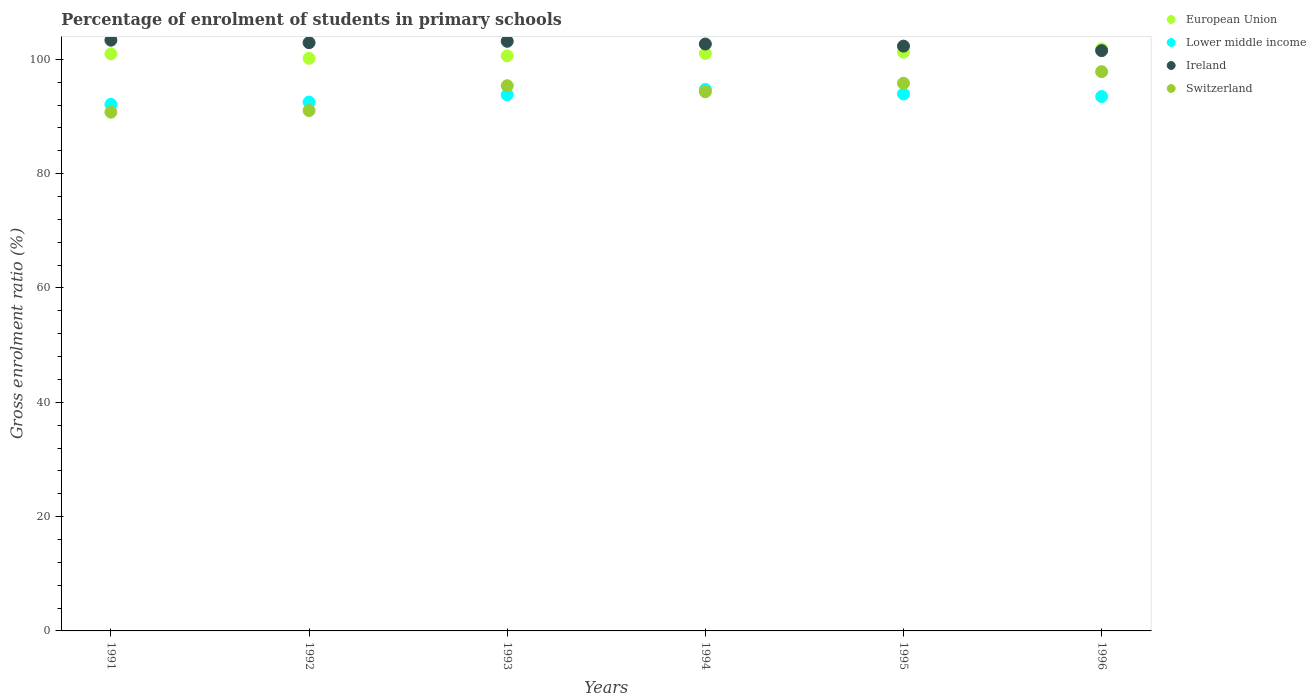Is the number of dotlines equal to the number of legend labels?
Your answer should be very brief. Yes. What is the percentage of students enrolled in primary schools in Ireland in 1993?
Make the answer very short. 103.16. Across all years, what is the maximum percentage of students enrolled in primary schools in European Union?
Offer a terse response. 101.84. Across all years, what is the minimum percentage of students enrolled in primary schools in Lower middle income?
Your response must be concise. 92.12. In which year was the percentage of students enrolled in primary schools in European Union minimum?
Provide a short and direct response. 1992. What is the total percentage of students enrolled in primary schools in Switzerland in the graph?
Keep it short and to the point. 565.19. What is the difference between the percentage of students enrolled in primary schools in European Union in 1992 and that in 1996?
Your response must be concise. -1.66. What is the difference between the percentage of students enrolled in primary schools in European Union in 1993 and the percentage of students enrolled in primary schools in Lower middle income in 1996?
Ensure brevity in your answer.  7.11. What is the average percentage of students enrolled in primary schools in Ireland per year?
Keep it short and to the point. 102.66. In the year 1991, what is the difference between the percentage of students enrolled in primary schools in Ireland and percentage of students enrolled in primary schools in Switzerland?
Provide a succinct answer. 12.59. What is the ratio of the percentage of students enrolled in primary schools in Lower middle income in 1992 to that in 1993?
Your answer should be compact. 0.99. Is the percentage of students enrolled in primary schools in Lower middle income in 1992 less than that in 1995?
Provide a succinct answer. Yes. Is the difference between the percentage of students enrolled in primary schools in Ireland in 1993 and 1994 greater than the difference between the percentage of students enrolled in primary schools in Switzerland in 1993 and 1994?
Your answer should be very brief. No. What is the difference between the highest and the second highest percentage of students enrolled in primary schools in Lower middle income?
Ensure brevity in your answer.  0.78. What is the difference between the highest and the lowest percentage of students enrolled in primary schools in Switzerland?
Keep it short and to the point. 7.09. Is it the case that in every year, the sum of the percentage of students enrolled in primary schools in Switzerland and percentage of students enrolled in primary schools in European Union  is greater than the sum of percentage of students enrolled in primary schools in Ireland and percentage of students enrolled in primary schools in Lower middle income?
Your response must be concise. Yes. Is it the case that in every year, the sum of the percentage of students enrolled in primary schools in European Union and percentage of students enrolled in primary schools in Lower middle income  is greater than the percentage of students enrolled in primary schools in Switzerland?
Provide a succinct answer. Yes. Is the percentage of students enrolled in primary schools in Lower middle income strictly greater than the percentage of students enrolled in primary schools in Ireland over the years?
Your answer should be very brief. No. Does the graph contain any zero values?
Offer a very short reply. No. Does the graph contain grids?
Provide a succinct answer. No. What is the title of the graph?
Offer a very short reply. Percentage of enrolment of students in primary schools. What is the label or title of the X-axis?
Provide a succinct answer. Years. What is the label or title of the Y-axis?
Offer a terse response. Gross enrolment ratio (%). What is the Gross enrolment ratio (%) in European Union in 1991?
Ensure brevity in your answer.  100.97. What is the Gross enrolment ratio (%) in Lower middle income in 1991?
Ensure brevity in your answer.  92.12. What is the Gross enrolment ratio (%) in Ireland in 1991?
Make the answer very short. 103.36. What is the Gross enrolment ratio (%) of Switzerland in 1991?
Offer a very short reply. 90.76. What is the Gross enrolment ratio (%) of European Union in 1992?
Provide a succinct answer. 100.18. What is the Gross enrolment ratio (%) in Lower middle income in 1992?
Offer a very short reply. 92.52. What is the Gross enrolment ratio (%) in Ireland in 1992?
Provide a succinct answer. 102.92. What is the Gross enrolment ratio (%) of Switzerland in 1992?
Ensure brevity in your answer.  91.04. What is the Gross enrolment ratio (%) in European Union in 1993?
Your answer should be compact. 100.61. What is the Gross enrolment ratio (%) of Lower middle income in 1993?
Offer a terse response. 93.81. What is the Gross enrolment ratio (%) of Ireland in 1993?
Make the answer very short. 103.16. What is the Gross enrolment ratio (%) of Switzerland in 1993?
Provide a short and direct response. 95.38. What is the Gross enrolment ratio (%) of European Union in 1994?
Offer a very short reply. 101.04. What is the Gross enrolment ratio (%) in Lower middle income in 1994?
Provide a succinct answer. 94.74. What is the Gross enrolment ratio (%) of Ireland in 1994?
Make the answer very short. 102.68. What is the Gross enrolment ratio (%) of Switzerland in 1994?
Provide a short and direct response. 94.33. What is the Gross enrolment ratio (%) of European Union in 1995?
Keep it short and to the point. 101.26. What is the Gross enrolment ratio (%) in Lower middle income in 1995?
Ensure brevity in your answer.  93.96. What is the Gross enrolment ratio (%) of Ireland in 1995?
Ensure brevity in your answer.  102.31. What is the Gross enrolment ratio (%) of Switzerland in 1995?
Your response must be concise. 95.83. What is the Gross enrolment ratio (%) in European Union in 1996?
Make the answer very short. 101.84. What is the Gross enrolment ratio (%) in Lower middle income in 1996?
Your response must be concise. 93.5. What is the Gross enrolment ratio (%) of Ireland in 1996?
Offer a very short reply. 101.52. What is the Gross enrolment ratio (%) of Switzerland in 1996?
Provide a succinct answer. 97.85. Across all years, what is the maximum Gross enrolment ratio (%) of European Union?
Offer a very short reply. 101.84. Across all years, what is the maximum Gross enrolment ratio (%) of Lower middle income?
Your answer should be compact. 94.74. Across all years, what is the maximum Gross enrolment ratio (%) in Ireland?
Make the answer very short. 103.36. Across all years, what is the maximum Gross enrolment ratio (%) of Switzerland?
Keep it short and to the point. 97.85. Across all years, what is the minimum Gross enrolment ratio (%) of European Union?
Provide a succinct answer. 100.18. Across all years, what is the minimum Gross enrolment ratio (%) of Lower middle income?
Make the answer very short. 92.12. Across all years, what is the minimum Gross enrolment ratio (%) in Ireland?
Give a very brief answer. 101.52. Across all years, what is the minimum Gross enrolment ratio (%) of Switzerland?
Offer a very short reply. 90.76. What is the total Gross enrolment ratio (%) in European Union in the graph?
Make the answer very short. 605.89. What is the total Gross enrolment ratio (%) of Lower middle income in the graph?
Give a very brief answer. 560.64. What is the total Gross enrolment ratio (%) in Ireland in the graph?
Give a very brief answer. 615.95. What is the total Gross enrolment ratio (%) of Switzerland in the graph?
Make the answer very short. 565.19. What is the difference between the Gross enrolment ratio (%) in European Union in 1991 and that in 1992?
Your response must be concise. 0.79. What is the difference between the Gross enrolment ratio (%) in Lower middle income in 1991 and that in 1992?
Your answer should be very brief. -0.4. What is the difference between the Gross enrolment ratio (%) in Ireland in 1991 and that in 1992?
Your response must be concise. 0.44. What is the difference between the Gross enrolment ratio (%) in Switzerland in 1991 and that in 1992?
Offer a terse response. -0.28. What is the difference between the Gross enrolment ratio (%) of European Union in 1991 and that in 1993?
Give a very brief answer. 0.35. What is the difference between the Gross enrolment ratio (%) of Lower middle income in 1991 and that in 1993?
Provide a succinct answer. -1.69. What is the difference between the Gross enrolment ratio (%) of Ireland in 1991 and that in 1993?
Your answer should be compact. 0.2. What is the difference between the Gross enrolment ratio (%) in Switzerland in 1991 and that in 1993?
Your response must be concise. -4.62. What is the difference between the Gross enrolment ratio (%) in European Union in 1991 and that in 1994?
Offer a very short reply. -0.07. What is the difference between the Gross enrolment ratio (%) of Lower middle income in 1991 and that in 1994?
Ensure brevity in your answer.  -2.62. What is the difference between the Gross enrolment ratio (%) of Ireland in 1991 and that in 1994?
Your answer should be compact. 0.67. What is the difference between the Gross enrolment ratio (%) of Switzerland in 1991 and that in 1994?
Provide a succinct answer. -3.57. What is the difference between the Gross enrolment ratio (%) of European Union in 1991 and that in 1995?
Offer a very short reply. -0.29. What is the difference between the Gross enrolment ratio (%) of Lower middle income in 1991 and that in 1995?
Your answer should be compact. -1.84. What is the difference between the Gross enrolment ratio (%) of Ireland in 1991 and that in 1995?
Make the answer very short. 1.04. What is the difference between the Gross enrolment ratio (%) of Switzerland in 1991 and that in 1995?
Keep it short and to the point. -5.06. What is the difference between the Gross enrolment ratio (%) of European Union in 1991 and that in 1996?
Provide a short and direct response. -0.87. What is the difference between the Gross enrolment ratio (%) of Lower middle income in 1991 and that in 1996?
Provide a short and direct response. -1.38. What is the difference between the Gross enrolment ratio (%) of Ireland in 1991 and that in 1996?
Make the answer very short. 1.83. What is the difference between the Gross enrolment ratio (%) of Switzerland in 1991 and that in 1996?
Offer a terse response. -7.09. What is the difference between the Gross enrolment ratio (%) of European Union in 1992 and that in 1993?
Provide a succinct answer. -0.43. What is the difference between the Gross enrolment ratio (%) of Lower middle income in 1992 and that in 1993?
Ensure brevity in your answer.  -1.29. What is the difference between the Gross enrolment ratio (%) in Ireland in 1992 and that in 1993?
Offer a terse response. -0.24. What is the difference between the Gross enrolment ratio (%) of Switzerland in 1992 and that in 1993?
Ensure brevity in your answer.  -4.34. What is the difference between the Gross enrolment ratio (%) of European Union in 1992 and that in 1994?
Offer a very short reply. -0.86. What is the difference between the Gross enrolment ratio (%) in Lower middle income in 1992 and that in 1994?
Your answer should be very brief. -2.22. What is the difference between the Gross enrolment ratio (%) of Ireland in 1992 and that in 1994?
Provide a succinct answer. 0.24. What is the difference between the Gross enrolment ratio (%) in Switzerland in 1992 and that in 1994?
Offer a terse response. -3.29. What is the difference between the Gross enrolment ratio (%) in European Union in 1992 and that in 1995?
Ensure brevity in your answer.  -1.08. What is the difference between the Gross enrolment ratio (%) of Lower middle income in 1992 and that in 1995?
Ensure brevity in your answer.  -1.44. What is the difference between the Gross enrolment ratio (%) in Ireland in 1992 and that in 1995?
Your answer should be compact. 0.6. What is the difference between the Gross enrolment ratio (%) of Switzerland in 1992 and that in 1995?
Ensure brevity in your answer.  -4.78. What is the difference between the Gross enrolment ratio (%) of European Union in 1992 and that in 1996?
Your answer should be very brief. -1.66. What is the difference between the Gross enrolment ratio (%) of Lower middle income in 1992 and that in 1996?
Give a very brief answer. -0.98. What is the difference between the Gross enrolment ratio (%) of Ireland in 1992 and that in 1996?
Give a very brief answer. 1.39. What is the difference between the Gross enrolment ratio (%) of Switzerland in 1992 and that in 1996?
Ensure brevity in your answer.  -6.8. What is the difference between the Gross enrolment ratio (%) in European Union in 1993 and that in 1994?
Make the answer very short. -0.43. What is the difference between the Gross enrolment ratio (%) in Lower middle income in 1993 and that in 1994?
Your answer should be very brief. -0.93. What is the difference between the Gross enrolment ratio (%) of Ireland in 1993 and that in 1994?
Your answer should be very brief. 0.48. What is the difference between the Gross enrolment ratio (%) of Switzerland in 1993 and that in 1994?
Provide a short and direct response. 1.05. What is the difference between the Gross enrolment ratio (%) in European Union in 1993 and that in 1995?
Give a very brief answer. -0.64. What is the difference between the Gross enrolment ratio (%) in Lower middle income in 1993 and that in 1995?
Ensure brevity in your answer.  -0.15. What is the difference between the Gross enrolment ratio (%) of Ireland in 1993 and that in 1995?
Offer a terse response. 0.85. What is the difference between the Gross enrolment ratio (%) of Switzerland in 1993 and that in 1995?
Your answer should be very brief. -0.44. What is the difference between the Gross enrolment ratio (%) of European Union in 1993 and that in 1996?
Ensure brevity in your answer.  -1.22. What is the difference between the Gross enrolment ratio (%) of Lower middle income in 1993 and that in 1996?
Provide a short and direct response. 0.31. What is the difference between the Gross enrolment ratio (%) of Ireland in 1993 and that in 1996?
Provide a short and direct response. 1.64. What is the difference between the Gross enrolment ratio (%) in Switzerland in 1993 and that in 1996?
Ensure brevity in your answer.  -2.47. What is the difference between the Gross enrolment ratio (%) of European Union in 1994 and that in 1995?
Provide a succinct answer. -0.22. What is the difference between the Gross enrolment ratio (%) in Lower middle income in 1994 and that in 1995?
Offer a terse response. 0.78. What is the difference between the Gross enrolment ratio (%) of Ireland in 1994 and that in 1995?
Ensure brevity in your answer.  0.37. What is the difference between the Gross enrolment ratio (%) of Switzerland in 1994 and that in 1995?
Provide a succinct answer. -1.49. What is the difference between the Gross enrolment ratio (%) of European Union in 1994 and that in 1996?
Provide a succinct answer. -0.79. What is the difference between the Gross enrolment ratio (%) of Lower middle income in 1994 and that in 1996?
Your answer should be compact. 1.24. What is the difference between the Gross enrolment ratio (%) in Ireland in 1994 and that in 1996?
Provide a short and direct response. 1.16. What is the difference between the Gross enrolment ratio (%) of Switzerland in 1994 and that in 1996?
Give a very brief answer. -3.52. What is the difference between the Gross enrolment ratio (%) of European Union in 1995 and that in 1996?
Provide a short and direct response. -0.58. What is the difference between the Gross enrolment ratio (%) of Lower middle income in 1995 and that in 1996?
Ensure brevity in your answer.  0.46. What is the difference between the Gross enrolment ratio (%) of Ireland in 1995 and that in 1996?
Offer a terse response. 0.79. What is the difference between the Gross enrolment ratio (%) in Switzerland in 1995 and that in 1996?
Your answer should be compact. -2.02. What is the difference between the Gross enrolment ratio (%) in European Union in 1991 and the Gross enrolment ratio (%) in Lower middle income in 1992?
Provide a succinct answer. 8.45. What is the difference between the Gross enrolment ratio (%) in European Union in 1991 and the Gross enrolment ratio (%) in Ireland in 1992?
Your answer should be very brief. -1.95. What is the difference between the Gross enrolment ratio (%) in European Union in 1991 and the Gross enrolment ratio (%) in Switzerland in 1992?
Offer a terse response. 9.92. What is the difference between the Gross enrolment ratio (%) of Lower middle income in 1991 and the Gross enrolment ratio (%) of Ireland in 1992?
Keep it short and to the point. -10.8. What is the difference between the Gross enrolment ratio (%) of Lower middle income in 1991 and the Gross enrolment ratio (%) of Switzerland in 1992?
Provide a short and direct response. 1.08. What is the difference between the Gross enrolment ratio (%) in Ireland in 1991 and the Gross enrolment ratio (%) in Switzerland in 1992?
Make the answer very short. 12.31. What is the difference between the Gross enrolment ratio (%) of European Union in 1991 and the Gross enrolment ratio (%) of Lower middle income in 1993?
Ensure brevity in your answer.  7.16. What is the difference between the Gross enrolment ratio (%) in European Union in 1991 and the Gross enrolment ratio (%) in Ireland in 1993?
Your response must be concise. -2.19. What is the difference between the Gross enrolment ratio (%) of European Union in 1991 and the Gross enrolment ratio (%) of Switzerland in 1993?
Offer a very short reply. 5.58. What is the difference between the Gross enrolment ratio (%) in Lower middle income in 1991 and the Gross enrolment ratio (%) in Ireland in 1993?
Give a very brief answer. -11.04. What is the difference between the Gross enrolment ratio (%) in Lower middle income in 1991 and the Gross enrolment ratio (%) in Switzerland in 1993?
Ensure brevity in your answer.  -3.26. What is the difference between the Gross enrolment ratio (%) of Ireland in 1991 and the Gross enrolment ratio (%) of Switzerland in 1993?
Make the answer very short. 7.97. What is the difference between the Gross enrolment ratio (%) of European Union in 1991 and the Gross enrolment ratio (%) of Lower middle income in 1994?
Provide a short and direct response. 6.23. What is the difference between the Gross enrolment ratio (%) in European Union in 1991 and the Gross enrolment ratio (%) in Ireland in 1994?
Offer a very short reply. -1.71. What is the difference between the Gross enrolment ratio (%) of European Union in 1991 and the Gross enrolment ratio (%) of Switzerland in 1994?
Offer a terse response. 6.64. What is the difference between the Gross enrolment ratio (%) in Lower middle income in 1991 and the Gross enrolment ratio (%) in Ireland in 1994?
Offer a very short reply. -10.56. What is the difference between the Gross enrolment ratio (%) of Lower middle income in 1991 and the Gross enrolment ratio (%) of Switzerland in 1994?
Ensure brevity in your answer.  -2.21. What is the difference between the Gross enrolment ratio (%) in Ireland in 1991 and the Gross enrolment ratio (%) in Switzerland in 1994?
Offer a terse response. 9.02. What is the difference between the Gross enrolment ratio (%) of European Union in 1991 and the Gross enrolment ratio (%) of Lower middle income in 1995?
Keep it short and to the point. 7.01. What is the difference between the Gross enrolment ratio (%) of European Union in 1991 and the Gross enrolment ratio (%) of Ireland in 1995?
Offer a very short reply. -1.35. What is the difference between the Gross enrolment ratio (%) in European Union in 1991 and the Gross enrolment ratio (%) in Switzerland in 1995?
Offer a very short reply. 5.14. What is the difference between the Gross enrolment ratio (%) of Lower middle income in 1991 and the Gross enrolment ratio (%) of Ireland in 1995?
Offer a very short reply. -10.19. What is the difference between the Gross enrolment ratio (%) in Lower middle income in 1991 and the Gross enrolment ratio (%) in Switzerland in 1995?
Provide a short and direct response. -3.7. What is the difference between the Gross enrolment ratio (%) in Ireland in 1991 and the Gross enrolment ratio (%) in Switzerland in 1995?
Provide a succinct answer. 7.53. What is the difference between the Gross enrolment ratio (%) of European Union in 1991 and the Gross enrolment ratio (%) of Lower middle income in 1996?
Your answer should be very brief. 7.47. What is the difference between the Gross enrolment ratio (%) of European Union in 1991 and the Gross enrolment ratio (%) of Ireland in 1996?
Your answer should be very brief. -0.56. What is the difference between the Gross enrolment ratio (%) in European Union in 1991 and the Gross enrolment ratio (%) in Switzerland in 1996?
Give a very brief answer. 3.12. What is the difference between the Gross enrolment ratio (%) in Lower middle income in 1991 and the Gross enrolment ratio (%) in Ireland in 1996?
Your answer should be compact. -9.4. What is the difference between the Gross enrolment ratio (%) of Lower middle income in 1991 and the Gross enrolment ratio (%) of Switzerland in 1996?
Your answer should be very brief. -5.73. What is the difference between the Gross enrolment ratio (%) of Ireland in 1991 and the Gross enrolment ratio (%) of Switzerland in 1996?
Offer a terse response. 5.51. What is the difference between the Gross enrolment ratio (%) of European Union in 1992 and the Gross enrolment ratio (%) of Lower middle income in 1993?
Make the answer very short. 6.37. What is the difference between the Gross enrolment ratio (%) in European Union in 1992 and the Gross enrolment ratio (%) in Ireland in 1993?
Keep it short and to the point. -2.98. What is the difference between the Gross enrolment ratio (%) in European Union in 1992 and the Gross enrolment ratio (%) in Switzerland in 1993?
Offer a very short reply. 4.8. What is the difference between the Gross enrolment ratio (%) of Lower middle income in 1992 and the Gross enrolment ratio (%) of Ireland in 1993?
Provide a succinct answer. -10.64. What is the difference between the Gross enrolment ratio (%) in Lower middle income in 1992 and the Gross enrolment ratio (%) in Switzerland in 1993?
Give a very brief answer. -2.86. What is the difference between the Gross enrolment ratio (%) of Ireland in 1992 and the Gross enrolment ratio (%) of Switzerland in 1993?
Provide a succinct answer. 7.53. What is the difference between the Gross enrolment ratio (%) in European Union in 1992 and the Gross enrolment ratio (%) in Lower middle income in 1994?
Ensure brevity in your answer.  5.44. What is the difference between the Gross enrolment ratio (%) of European Union in 1992 and the Gross enrolment ratio (%) of Ireland in 1994?
Your response must be concise. -2.5. What is the difference between the Gross enrolment ratio (%) of European Union in 1992 and the Gross enrolment ratio (%) of Switzerland in 1994?
Give a very brief answer. 5.85. What is the difference between the Gross enrolment ratio (%) in Lower middle income in 1992 and the Gross enrolment ratio (%) in Ireland in 1994?
Offer a very short reply. -10.16. What is the difference between the Gross enrolment ratio (%) of Lower middle income in 1992 and the Gross enrolment ratio (%) of Switzerland in 1994?
Provide a short and direct response. -1.81. What is the difference between the Gross enrolment ratio (%) of Ireland in 1992 and the Gross enrolment ratio (%) of Switzerland in 1994?
Provide a succinct answer. 8.59. What is the difference between the Gross enrolment ratio (%) in European Union in 1992 and the Gross enrolment ratio (%) in Lower middle income in 1995?
Make the answer very short. 6.22. What is the difference between the Gross enrolment ratio (%) of European Union in 1992 and the Gross enrolment ratio (%) of Ireland in 1995?
Make the answer very short. -2.13. What is the difference between the Gross enrolment ratio (%) in European Union in 1992 and the Gross enrolment ratio (%) in Switzerland in 1995?
Offer a very short reply. 4.35. What is the difference between the Gross enrolment ratio (%) of Lower middle income in 1992 and the Gross enrolment ratio (%) of Ireland in 1995?
Provide a succinct answer. -9.79. What is the difference between the Gross enrolment ratio (%) in Lower middle income in 1992 and the Gross enrolment ratio (%) in Switzerland in 1995?
Offer a very short reply. -3.3. What is the difference between the Gross enrolment ratio (%) in Ireland in 1992 and the Gross enrolment ratio (%) in Switzerland in 1995?
Give a very brief answer. 7.09. What is the difference between the Gross enrolment ratio (%) in European Union in 1992 and the Gross enrolment ratio (%) in Lower middle income in 1996?
Give a very brief answer. 6.68. What is the difference between the Gross enrolment ratio (%) of European Union in 1992 and the Gross enrolment ratio (%) of Ireland in 1996?
Make the answer very short. -1.34. What is the difference between the Gross enrolment ratio (%) of European Union in 1992 and the Gross enrolment ratio (%) of Switzerland in 1996?
Your response must be concise. 2.33. What is the difference between the Gross enrolment ratio (%) of Lower middle income in 1992 and the Gross enrolment ratio (%) of Ireland in 1996?
Your response must be concise. -9. What is the difference between the Gross enrolment ratio (%) in Lower middle income in 1992 and the Gross enrolment ratio (%) in Switzerland in 1996?
Give a very brief answer. -5.33. What is the difference between the Gross enrolment ratio (%) of Ireland in 1992 and the Gross enrolment ratio (%) of Switzerland in 1996?
Offer a terse response. 5.07. What is the difference between the Gross enrolment ratio (%) in European Union in 1993 and the Gross enrolment ratio (%) in Lower middle income in 1994?
Ensure brevity in your answer.  5.88. What is the difference between the Gross enrolment ratio (%) in European Union in 1993 and the Gross enrolment ratio (%) in Ireland in 1994?
Provide a short and direct response. -2.07. What is the difference between the Gross enrolment ratio (%) of European Union in 1993 and the Gross enrolment ratio (%) of Switzerland in 1994?
Your answer should be very brief. 6.28. What is the difference between the Gross enrolment ratio (%) of Lower middle income in 1993 and the Gross enrolment ratio (%) of Ireland in 1994?
Your answer should be compact. -8.87. What is the difference between the Gross enrolment ratio (%) in Lower middle income in 1993 and the Gross enrolment ratio (%) in Switzerland in 1994?
Make the answer very short. -0.52. What is the difference between the Gross enrolment ratio (%) in Ireland in 1993 and the Gross enrolment ratio (%) in Switzerland in 1994?
Your answer should be compact. 8.83. What is the difference between the Gross enrolment ratio (%) of European Union in 1993 and the Gross enrolment ratio (%) of Lower middle income in 1995?
Give a very brief answer. 6.65. What is the difference between the Gross enrolment ratio (%) in European Union in 1993 and the Gross enrolment ratio (%) in Ireland in 1995?
Your response must be concise. -1.7. What is the difference between the Gross enrolment ratio (%) of European Union in 1993 and the Gross enrolment ratio (%) of Switzerland in 1995?
Your answer should be compact. 4.79. What is the difference between the Gross enrolment ratio (%) of Lower middle income in 1993 and the Gross enrolment ratio (%) of Ireland in 1995?
Ensure brevity in your answer.  -8.5. What is the difference between the Gross enrolment ratio (%) in Lower middle income in 1993 and the Gross enrolment ratio (%) in Switzerland in 1995?
Your response must be concise. -2.02. What is the difference between the Gross enrolment ratio (%) in Ireland in 1993 and the Gross enrolment ratio (%) in Switzerland in 1995?
Your answer should be very brief. 7.33. What is the difference between the Gross enrolment ratio (%) of European Union in 1993 and the Gross enrolment ratio (%) of Lower middle income in 1996?
Ensure brevity in your answer.  7.11. What is the difference between the Gross enrolment ratio (%) in European Union in 1993 and the Gross enrolment ratio (%) in Ireland in 1996?
Give a very brief answer. -0.91. What is the difference between the Gross enrolment ratio (%) of European Union in 1993 and the Gross enrolment ratio (%) of Switzerland in 1996?
Keep it short and to the point. 2.76. What is the difference between the Gross enrolment ratio (%) of Lower middle income in 1993 and the Gross enrolment ratio (%) of Ireland in 1996?
Keep it short and to the point. -7.71. What is the difference between the Gross enrolment ratio (%) of Lower middle income in 1993 and the Gross enrolment ratio (%) of Switzerland in 1996?
Make the answer very short. -4.04. What is the difference between the Gross enrolment ratio (%) of Ireland in 1993 and the Gross enrolment ratio (%) of Switzerland in 1996?
Make the answer very short. 5.31. What is the difference between the Gross enrolment ratio (%) in European Union in 1994 and the Gross enrolment ratio (%) in Lower middle income in 1995?
Make the answer very short. 7.08. What is the difference between the Gross enrolment ratio (%) in European Union in 1994 and the Gross enrolment ratio (%) in Ireland in 1995?
Your response must be concise. -1.27. What is the difference between the Gross enrolment ratio (%) of European Union in 1994 and the Gross enrolment ratio (%) of Switzerland in 1995?
Offer a very short reply. 5.22. What is the difference between the Gross enrolment ratio (%) in Lower middle income in 1994 and the Gross enrolment ratio (%) in Ireland in 1995?
Provide a short and direct response. -7.58. What is the difference between the Gross enrolment ratio (%) in Lower middle income in 1994 and the Gross enrolment ratio (%) in Switzerland in 1995?
Keep it short and to the point. -1.09. What is the difference between the Gross enrolment ratio (%) in Ireland in 1994 and the Gross enrolment ratio (%) in Switzerland in 1995?
Give a very brief answer. 6.86. What is the difference between the Gross enrolment ratio (%) in European Union in 1994 and the Gross enrolment ratio (%) in Lower middle income in 1996?
Make the answer very short. 7.54. What is the difference between the Gross enrolment ratio (%) of European Union in 1994 and the Gross enrolment ratio (%) of Ireland in 1996?
Ensure brevity in your answer.  -0.48. What is the difference between the Gross enrolment ratio (%) of European Union in 1994 and the Gross enrolment ratio (%) of Switzerland in 1996?
Offer a very short reply. 3.19. What is the difference between the Gross enrolment ratio (%) of Lower middle income in 1994 and the Gross enrolment ratio (%) of Ireland in 1996?
Provide a short and direct response. -6.79. What is the difference between the Gross enrolment ratio (%) in Lower middle income in 1994 and the Gross enrolment ratio (%) in Switzerland in 1996?
Give a very brief answer. -3.11. What is the difference between the Gross enrolment ratio (%) of Ireland in 1994 and the Gross enrolment ratio (%) of Switzerland in 1996?
Provide a succinct answer. 4.83. What is the difference between the Gross enrolment ratio (%) of European Union in 1995 and the Gross enrolment ratio (%) of Lower middle income in 1996?
Ensure brevity in your answer.  7.76. What is the difference between the Gross enrolment ratio (%) in European Union in 1995 and the Gross enrolment ratio (%) in Ireland in 1996?
Provide a short and direct response. -0.27. What is the difference between the Gross enrolment ratio (%) of European Union in 1995 and the Gross enrolment ratio (%) of Switzerland in 1996?
Your response must be concise. 3.41. What is the difference between the Gross enrolment ratio (%) in Lower middle income in 1995 and the Gross enrolment ratio (%) in Ireland in 1996?
Your answer should be compact. -7.57. What is the difference between the Gross enrolment ratio (%) of Lower middle income in 1995 and the Gross enrolment ratio (%) of Switzerland in 1996?
Give a very brief answer. -3.89. What is the difference between the Gross enrolment ratio (%) of Ireland in 1995 and the Gross enrolment ratio (%) of Switzerland in 1996?
Provide a short and direct response. 4.46. What is the average Gross enrolment ratio (%) in European Union per year?
Offer a very short reply. 100.98. What is the average Gross enrolment ratio (%) in Lower middle income per year?
Your answer should be compact. 93.44. What is the average Gross enrolment ratio (%) of Ireland per year?
Provide a succinct answer. 102.66. What is the average Gross enrolment ratio (%) of Switzerland per year?
Your answer should be compact. 94.2. In the year 1991, what is the difference between the Gross enrolment ratio (%) of European Union and Gross enrolment ratio (%) of Lower middle income?
Keep it short and to the point. 8.85. In the year 1991, what is the difference between the Gross enrolment ratio (%) in European Union and Gross enrolment ratio (%) in Ireland?
Provide a succinct answer. -2.39. In the year 1991, what is the difference between the Gross enrolment ratio (%) of European Union and Gross enrolment ratio (%) of Switzerland?
Ensure brevity in your answer.  10.21. In the year 1991, what is the difference between the Gross enrolment ratio (%) in Lower middle income and Gross enrolment ratio (%) in Ireland?
Offer a terse response. -11.23. In the year 1991, what is the difference between the Gross enrolment ratio (%) in Lower middle income and Gross enrolment ratio (%) in Switzerland?
Your answer should be compact. 1.36. In the year 1991, what is the difference between the Gross enrolment ratio (%) of Ireland and Gross enrolment ratio (%) of Switzerland?
Ensure brevity in your answer.  12.59. In the year 1992, what is the difference between the Gross enrolment ratio (%) in European Union and Gross enrolment ratio (%) in Lower middle income?
Provide a succinct answer. 7.66. In the year 1992, what is the difference between the Gross enrolment ratio (%) of European Union and Gross enrolment ratio (%) of Ireland?
Offer a terse response. -2.74. In the year 1992, what is the difference between the Gross enrolment ratio (%) in European Union and Gross enrolment ratio (%) in Switzerland?
Offer a very short reply. 9.14. In the year 1992, what is the difference between the Gross enrolment ratio (%) of Lower middle income and Gross enrolment ratio (%) of Ireland?
Provide a short and direct response. -10.4. In the year 1992, what is the difference between the Gross enrolment ratio (%) of Lower middle income and Gross enrolment ratio (%) of Switzerland?
Your response must be concise. 1.48. In the year 1992, what is the difference between the Gross enrolment ratio (%) in Ireland and Gross enrolment ratio (%) in Switzerland?
Offer a very short reply. 11.87. In the year 1993, what is the difference between the Gross enrolment ratio (%) in European Union and Gross enrolment ratio (%) in Lower middle income?
Make the answer very short. 6.8. In the year 1993, what is the difference between the Gross enrolment ratio (%) in European Union and Gross enrolment ratio (%) in Ireland?
Keep it short and to the point. -2.55. In the year 1993, what is the difference between the Gross enrolment ratio (%) of European Union and Gross enrolment ratio (%) of Switzerland?
Your response must be concise. 5.23. In the year 1993, what is the difference between the Gross enrolment ratio (%) of Lower middle income and Gross enrolment ratio (%) of Ireland?
Your answer should be compact. -9.35. In the year 1993, what is the difference between the Gross enrolment ratio (%) of Lower middle income and Gross enrolment ratio (%) of Switzerland?
Make the answer very short. -1.57. In the year 1993, what is the difference between the Gross enrolment ratio (%) of Ireland and Gross enrolment ratio (%) of Switzerland?
Provide a short and direct response. 7.78. In the year 1994, what is the difference between the Gross enrolment ratio (%) in European Union and Gross enrolment ratio (%) in Lower middle income?
Offer a very short reply. 6.3. In the year 1994, what is the difference between the Gross enrolment ratio (%) in European Union and Gross enrolment ratio (%) in Ireland?
Provide a succinct answer. -1.64. In the year 1994, what is the difference between the Gross enrolment ratio (%) of European Union and Gross enrolment ratio (%) of Switzerland?
Offer a very short reply. 6.71. In the year 1994, what is the difference between the Gross enrolment ratio (%) in Lower middle income and Gross enrolment ratio (%) in Ireland?
Ensure brevity in your answer.  -7.94. In the year 1994, what is the difference between the Gross enrolment ratio (%) in Lower middle income and Gross enrolment ratio (%) in Switzerland?
Provide a succinct answer. 0.41. In the year 1994, what is the difference between the Gross enrolment ratio (%) in Ireland and Gross enrolment ratio (%) in Switzerland?
Provide a short and direct response. 8.35. In the year 1995, what is the difference between the Gross enrolment ratio (%) of European Union and Gross enrolment ratio (%) of Lower middle income?
Provide a short and direct response. 7.3. In the year 1995, what is the difference between the Gross enrolment ratio (%) in European Union and Gross enrolment ratio (%) in Ireland?
Keep it short and to the point. -1.06. In the year 1995, what is the difference between the Gross enrolment ratio (%) in European Union and Gross enrolment ratio (%) in Switzerland?
Give a very brief answer. 5.43. In the year 1995, what is the difference between the Gross enrolment ratio (%) of Lower middle income and Gross enrolment ratio (%) of Ireland?
Provide a succinct answer. -8.36. In the year 1995, what is the difference between the Gross enrolment ratio (%) in Lower middle income and Gross enrolment ratio (%) in Switzerland?
Ensure brevity in your answer.  -1.87. In the year 1995, what is the difference between the Gross enrolment ratio (%) in Ireland and Gross enrolment ratio (%) in Switzerland?
Provide a succinct answer. 6.49. In the year 1996, what is the difference between the Gross enrolment ratio (%) in European Union and Gross enrolment ratio (%) in Lower middle income?
Your answer should be very brief. 8.34. In the year 1996, what is the difference between the Gross enrolment ratio (%) of European Union and Gross enrolment ratio (%) of Ireland?
Offer a terse response. 0.31. In the year 1996, what is the difference between the Gross enrolment ratio (%) in European Union and Gross enrolment ratio (%) in Switzerland?
Make the answer very short. 3.99. In the year 1996, what is the difference between the Gross enrolment ratio (%) of Lower middle income and Gross enrolment ratio (%) of Ireland?
Offer a terse response. -8.02. In the year 1996, what is the difference between the Gross enrolment ratio (%) in Lower middle income and Gross enrolment ratio (%) in Switzerland?
Provide a short and direct response. -4.35. In the year 1996, what is the difference between the Gross enrolment ratio (%) of Ireland and Gross enrolment ratio (%) of Switzerland?
Your response must be concise. 3.67. What is the ratio of the Gross enrolment ratio (%) in European Union in 1991 to that in 1992?
Your answer should be very brief. 1.01. What is the ratio of the Gross enrolment ratio (%) in Ireland in 1991 to that in 1993?
Give a very brief answer. 1. What is the ratio of the Gross enrolment ratio (%) in Switzerland in 1991 to that in 1993?
Offer a very short reply. 0.95. What is the ratio of the Gross enrolment ratio (%) in European Union in 1991 to that in 1994?
Provide a succinct answer. 1. What is the ratio of the Gross enrolment ratio (%) of Lower middle income in 1991 to that in 1994?
Your answer should be very brief. 0.97. What is the ratio of the Gross enrolment ratio (%) in Ireland in 1991 to that in 1994?
Provide a short and direct response. 1.01. What is the ratio of the Gross enrolment ratio (%) of Switzerland in 1991 to that in 1994?
Offer a terse response. 0.96. What is the ratio of the Gross enrolment ratio (%) in Lower middle income in 1991 to that in 1995?
Provide a succinct answer. 0.98. What is the ratio of the Gross enrolment ratio (%) of Ireland in 1991 to that in 1995?
Make the answer very short. 1.01. What is the ratio of the Gross enrolment ratio (%) of Switzerland in 1991 to that in 1995?
Your answer should be compact. 0.95. What is the ratio of the Gross enrolment ratio (%) in Lower middle income in 1991 to that in 1996?
Give a very brief answer. 0.99. What is the ratio of the Gross enrolment ratio (%) in Ireland in 1991 to that in 1996?
Your answer should be very brief. 1.02. What is the ratio of the Gross enrolment ratio (%) in Switzerland in 1991 to that in 1996?
Offer a terse response. 0.93. What is the ratio of the Gross enrolment ratio (%) in European Union in 1992 to that in 1993?
Offer a very short reply. 1. What is the ratio of the Gross enrolment ratio (%) of Lower middle income in 1992 to that in 1993?
Ensure brevity in your answer.  0.99. What is the ratio of the Gross enrolment ratio (%) in Ireland in 1992 to that in 1993?
Your response must be concise. 1. What is the ratio of the Gross enrolment ratio (%) of Switzerland in 1992 to that in 1993?
Offer a terse response. 0.95. What is the ratio of the Gross enrolment ratio (%) in Lower middle income in 1992 to that in 1994?
Provide a short and direct response. 0.98. What is the ratio of the Gross enrolment ratio (%) in Ireland in 1992 to that in 1994?
Make the answer very short. 1. What is the ratio of the Gross enrolment ratio (%) in Switzerland in 1992 to that in 1994?
Your answer should be very brief. 0.97. What is the ratio of the Gross enrolment ratio (%) in Lower middle income in 1992 to that in 1995?
Your answer should be very brief. 0.98. What is the ratio of the Gross enrolment ratio (%) in Ireland in 1992 to that in 1995?
Give a very brief answer. 1.01. What is the ratio of the Gross enrolment ratio (%) in Switzerland in 1992 to that in 1995?
Provide a short and direct response. 0.95. What is the ratio of the Gross enrolment ratio (%) in European Union in 1992 to that in 1996?
Ensure brevity in your answer.  0.98. What is the ratio of the Gross enrolment ratio (%) in Lower middle income in 1992 to that in 1996?
Your response must be concise. 0.99. What is the ratio of the Gross enrolment ratio (%) of Ireland in 1992 to that in 1996?
Your answer should be compact. 1.01. What is the ratio of the Gross enrolment ratio (%) in Switzerland in 1992 to that in 1996?
Your answer should be compact. 0.93. What is the ratio of the Gross enrolment ratio (%) of Lower middle income in 1993 to that in 1994?
Your answer should be compact. 0.99. What is the ratio of the Gross enrolment ratio (%) of Switzerland in 1993 to that in 1994?
Keep it short and to the point. 1.01. What is the ratio of the Gross enrolment ratio (%) in Ireland in 1993 to that in 1995?
Offer a terse response. 1.01. What is the ratio of the Gross enrolment ratio (%) in European Union in 1993 to that in 1996?
Give a very brief answer. 0.99. What is the ratio of the Gross enrolment ratio (%) of Lower middle income in 1993 to that in 1996?
Your answer should be compact. 1. What is the ratio of the Gross enrolment ratio (%) in Ireland in 1993 to that in 1996?
Provide a succinct answer. 1.02. What is the ratio of the Gross enrolment ratio (%) in Switzerland in 1993 to that in 1996?
Make the answer very short. 0.97. What is the ratio of the Gross enrolment ratio (%) in Lower middle income in 1994 to that in 1995?
Your answer should be very brief. 1.01. What is the ratio of the Gross enrolment ratio (%) in Ireland in 1994 to that in 1995?
Ensure brevity in your answer.  1. What is the ratio of the Gross enrolment ratio (%) of Switzerland in 1994 to that in 1995?
Offer a terse response. 0.98. What is the ratio of the Gross enrolment ratio (%) of Lower middle income in 1994 to that in 1996?
Offer a very short reply. 1.01. What is the ratio of the Gross enrolment ratio (%) in Ireland in 1994 to that in 1996?
Provide a succinct answer. 1.01. What is the ratio of the Gross enrolment ratio (%) of Switzerland in 1994 to that in 1996?
Provide a short and direct response. 0.96. What is the ratio of the Gross enrolment ratio (%) in Switzerland in 1995 to that in 1996?
Provide a short and direct response. 0.98. What is the difference between the highest and the second highest Gross enrolment ratio (%) of European Union?
Offer a terse response. 0.58. What is the difference between the highest and the second highest Gross enrolment ratio (%) of Lower middle income?
Give a very brief answer. 0.78. What is the difference between the highest and the second highest Gross enrolment ratio (%) of Ireland?
Your answer should be very brief. 0.2. What is the difference between the highest and the second highest Gross enrolment ratio (%) of Switzerland?
Your answer should be compact. 2.02. What is the difference between the highest and the lowest Gross enrolment ratio (%) in European Union?
Provide a succinct answer. 1.66. What is the difference between the highest and the lowest Gross enrolment ratio (%) of Lower middle income?
Keep it short and to the point. 2.62. What is the difference between the highest and the lowest Gross enrolment ratio (%) of Ireland?
Give a very brief answer. 1.83. What is the difference between the highest and the lowest Gross enrolment ratio (%) of Switzerland?
Offer a very short reply. 7.09. 